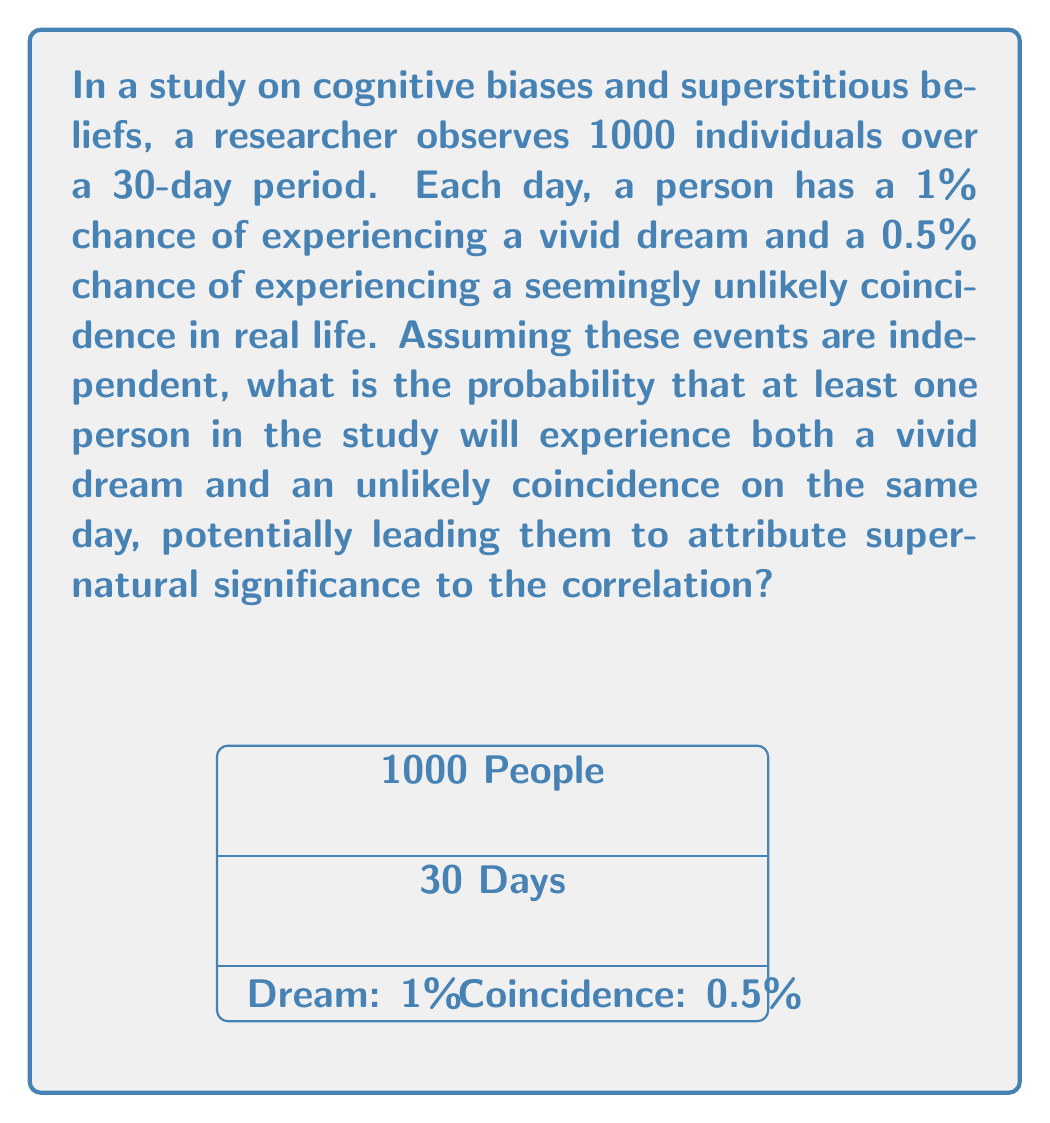What is the answer to this math problem? Let's approach this step-by-step:

1) First, we need to calculate the probability of a person experiencing both events on a single day:
   $P(\text{both events}) = P(\text{dream}) \times P(\text{coincidence}) = 0.01 \times 0.005 = 0.00005$

2) The probability of not experiencing both events on a single day is:
   $P(\text{not both}) = 1 - 0.00005 = 0.99995$

3) For a person to not experience both events on any day over the 30-day period:
   $P(\text{no days with both}) = (0.99995)^{30} \approx 0.99850$

4) Therefore, the probability of a person experiencing both events at least once in 30 days is:
   $P(\text{at least once in 30 days}) = 1 - 0.99850 \approx 0.00150$

5) Now, we need to calculate the probability that none of the 1000 people experience both events:
   $P(\text{no one experiences both}) = (0.99850)^{1000} \approx 0.22313$

6) Finally, the probability that at least one person experiences both events is:
   $P(\text{at least one person}) = 1 - 0.22313 \approx 0.77687$

Thus, there is approximately a 77.69% chance that at least one person in the study will experience both a vivid dream and an unlikely coincidence on the same day.
Answer: $1 - (1 - 0.00005)^{30})^{1000} \approx 0.77687$ or $77.69\%$ 